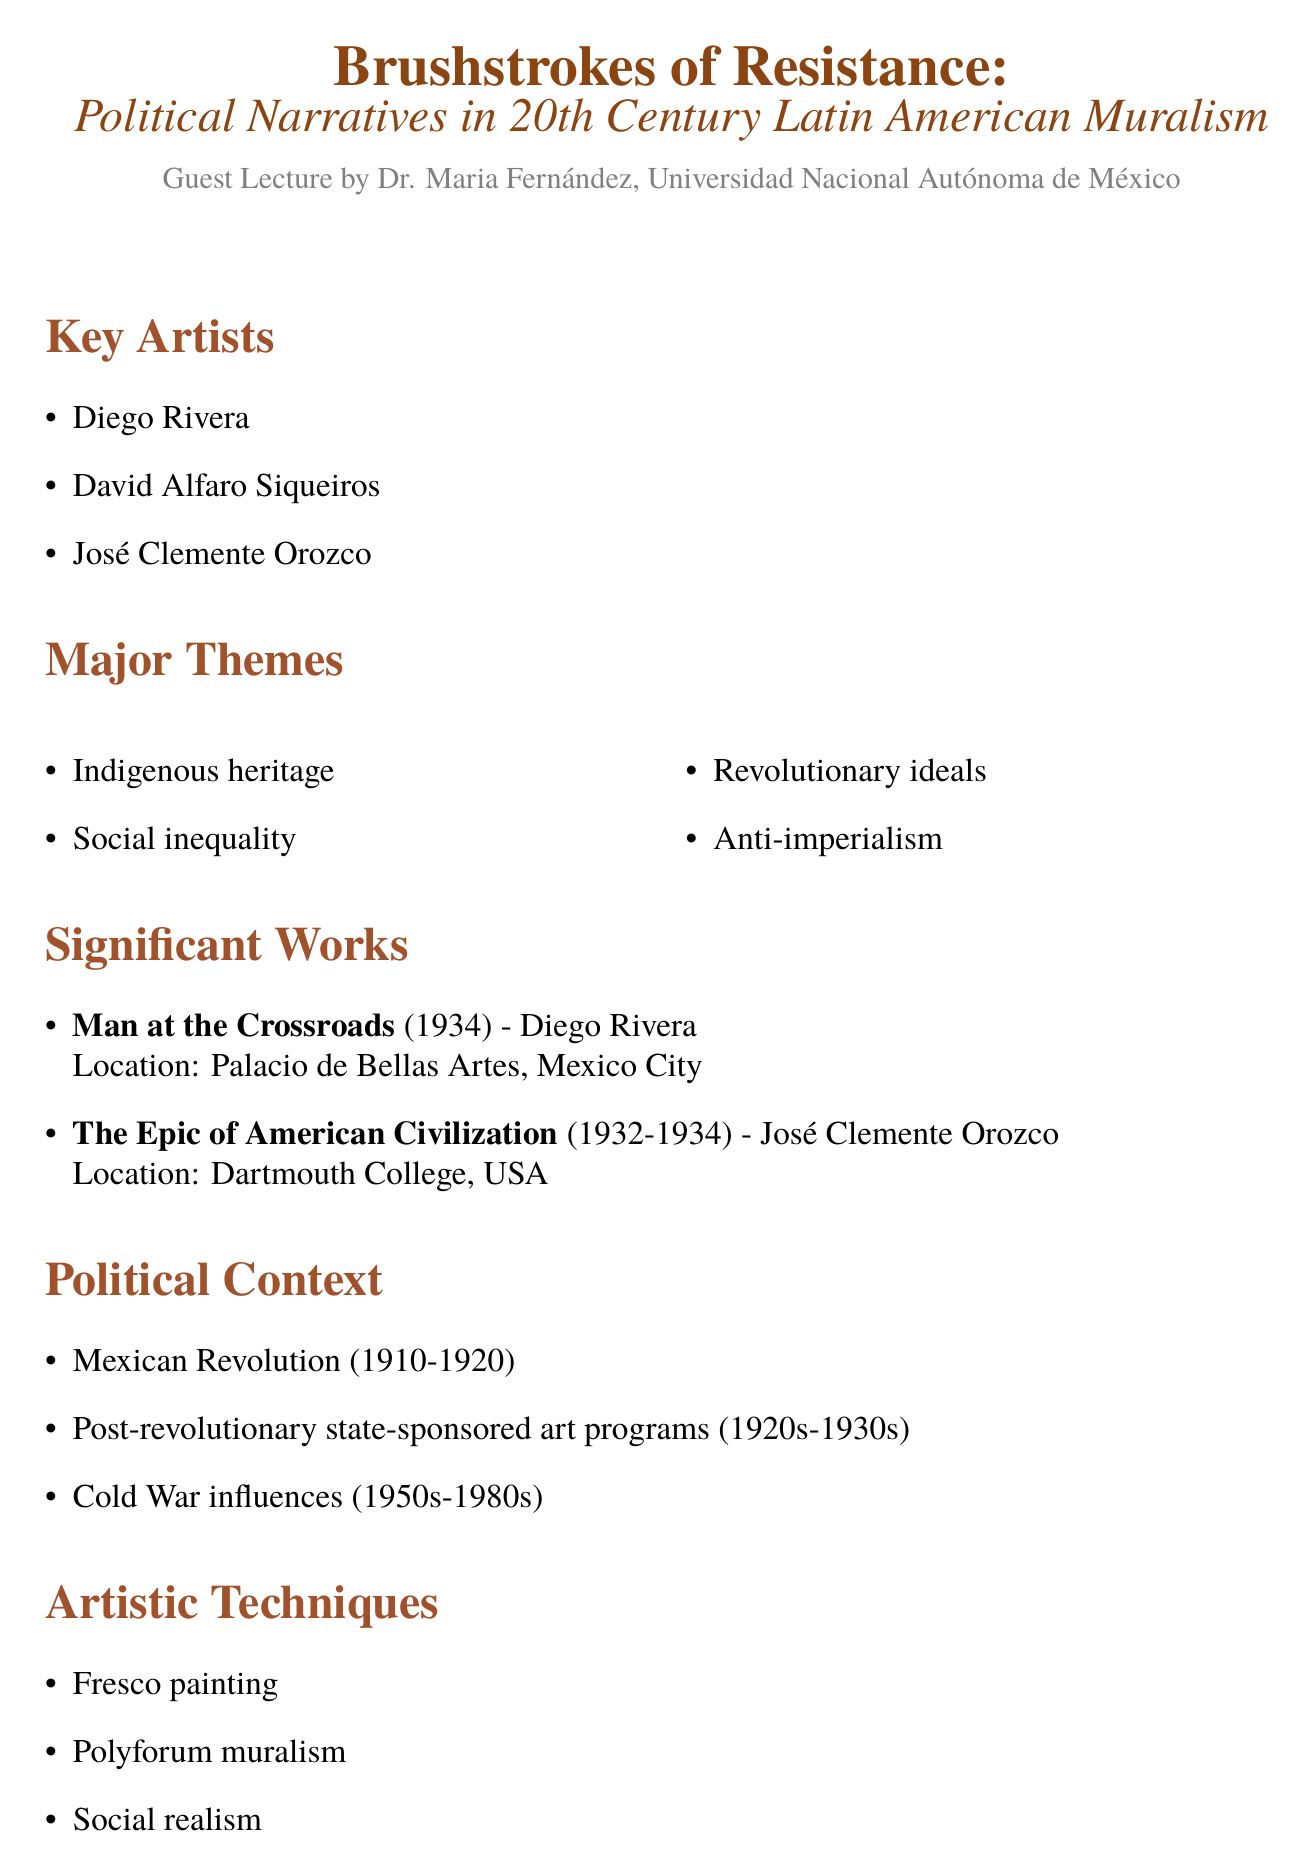What is the title of the lecture? The title of the lecture is provided in the document, specifying the focus on political narratives in muralism.
Answer: Brushstrokes of Resistance: Political Narratives in 20th Century Latin American Muralism Who is the speaker at the lecture? The speaker is identified as a specific individual representing an institution in Mexico.
Answer: Dr. Maria Fernández In what years did the Mexican Revolution occur? The document provides specific dates for the Mexican Revolution, providing context for the art discussed.
Answer: 1910-1920 What artistic technique is mentioned in the document? One of the listed artistic techniques reveals a specific style used in the murals discussed.
Answer: Fresco painting Which artist created "The Epic of American Civilization"? The document names the artist associated with a significant work of muralism, linking art to its creator.
Answer: José Clemente Orozco What major theme addresses the issue of societal disparities? A theme mentioned in the document reflects a critical social issue prevalent in the murals.
Answer: Social inequality What was the impact of state-sponsored art programs? An analysis of the political context reveals the effects of these programs on artistic expression.
Answer: 1920s-1930s What is one legacy of Latin American muralism? The document lists contemporary movements that owe their origin or inspiration to earlier muralism.
Answer: Chicano mural movement in the United States What does the document suggest about gender representation? The critical analysis section discusses the dominance of one gender in the narratives of muralism.
Answer: Male-dominated narratives 